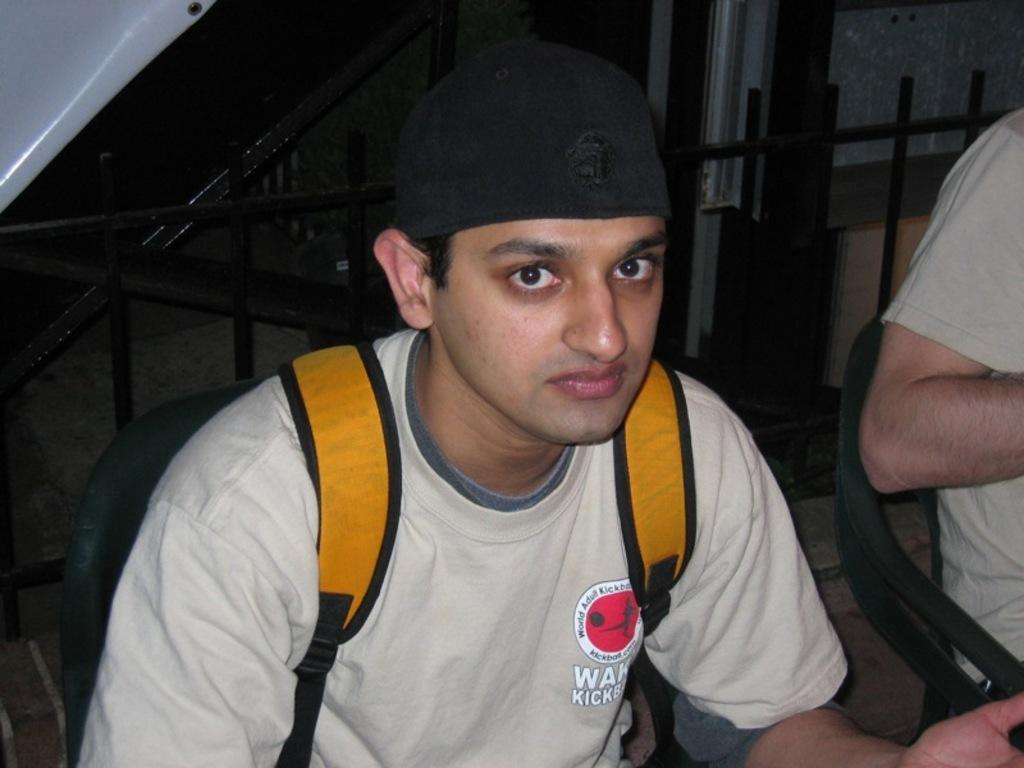How many people are sitting in the image? There are two persons sitting in the image. What is the person in front wearing? The person in front is wearing a cream-colored shirt. What color is the bag that the person in front is carrying? The person in front has an orange-colored bag. What can be seen in the background of the image? There is a railing visible in the background of the image. How many cherries are on the person's feet in the image? There are no cherries or reference to feet in the image. What type of jewel is the person wearing in the image? There is no mention of a jewel or any accessory that could be considered a jewel in the image. 